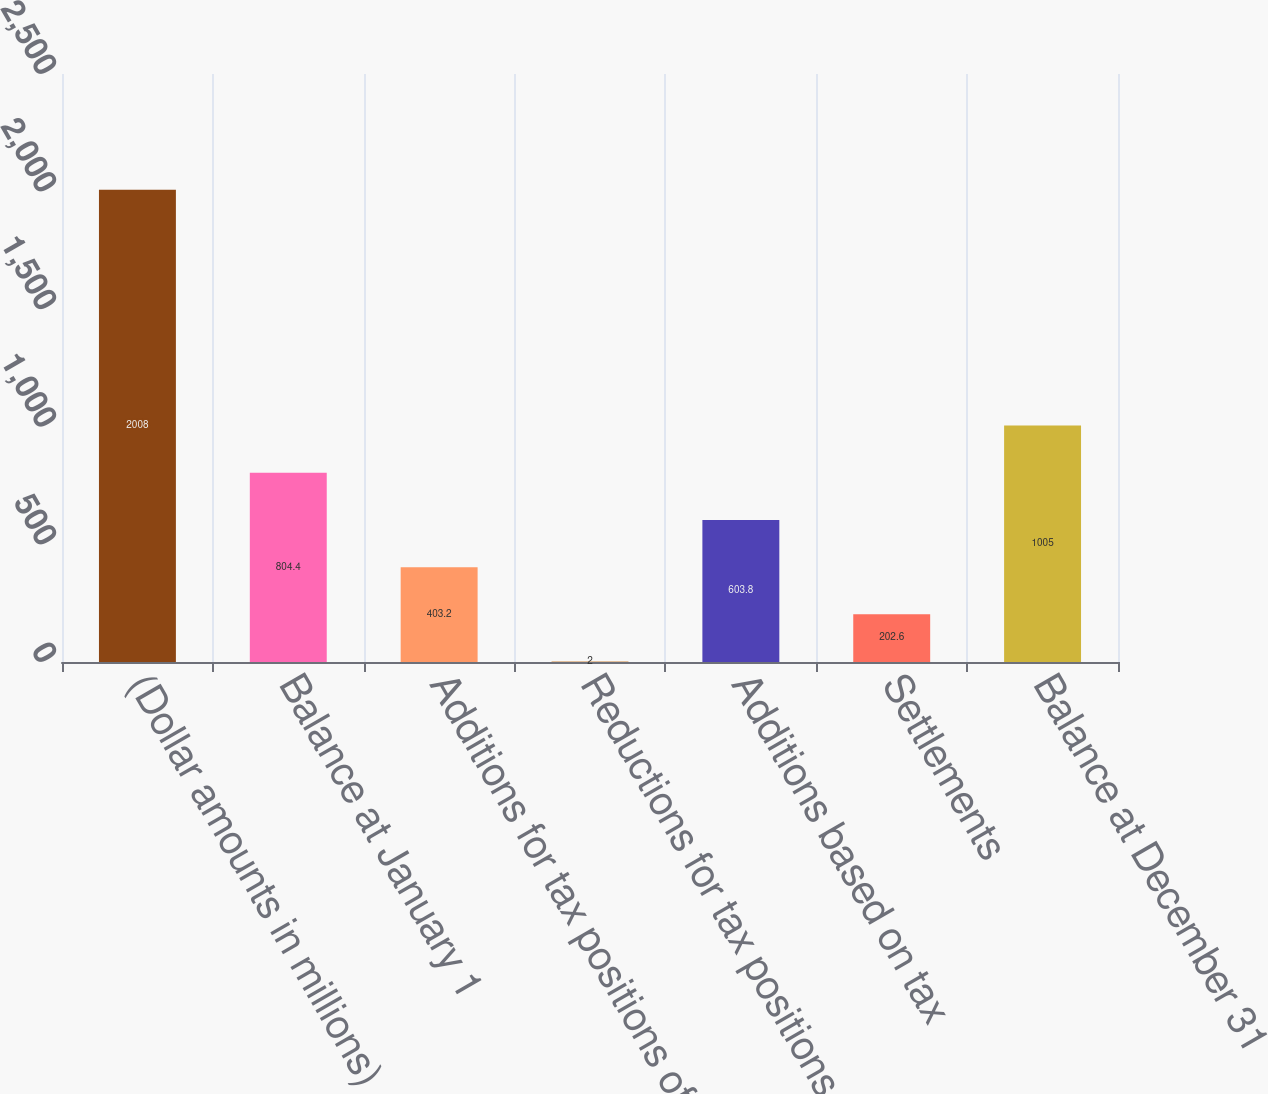<chart> <loc_0><loc_0><loc_500><loc_500><bar_chart><fcel>(Dollar amounts in millions)<fcel>Balance at January 1<fcel>Additions for tax positions of<fcel>Reductions for tax positions<fcel>Additions based on tax<fcel>Settlements<fcel>Balance at December 31<nl><fcel>2008<fcel>804.4<fcel>403.2<fcel>2<fcel>603.8<fcel>202.6<fcel>1005<nl></chart> 